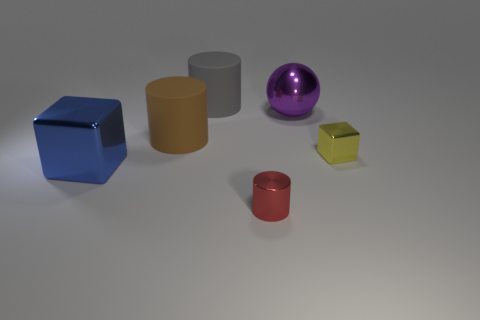Subtract all large cylinders. How many cylinders are left? 1 Subtract 1 cylinders. How many cylinders are left? 2 Add 2 small red objects. How many objects exist? 8 Subtract all cyan cylinders. How many blue blocks are left? 1 Add 4 metallic things. How many metallic things are left? 8 Add 5 big gray cylinders. How many big gray cylinders exist? 6 Subtract all brown cylinders. How many cylinders are left? 2 Subtract 0 yellow cylinders. How many objects are left? 6 Subtract all cubes. How many objects are left? 4 Subtract all brown cylinders. Subtract all brown cubes. How many cylinders are left? 2 